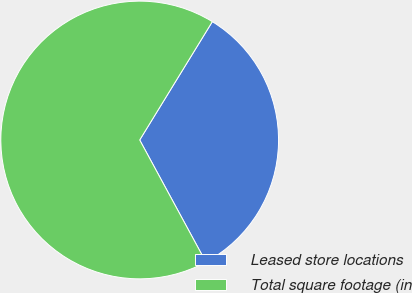Convert chart. <chart><loc_0><loc_0><loc_500><loc_500><pie_chart><fcel>Leased store locations<fcel>Total square footage (in<nl><fcel>33.33%<fcel>66.67%<nl></chart> 